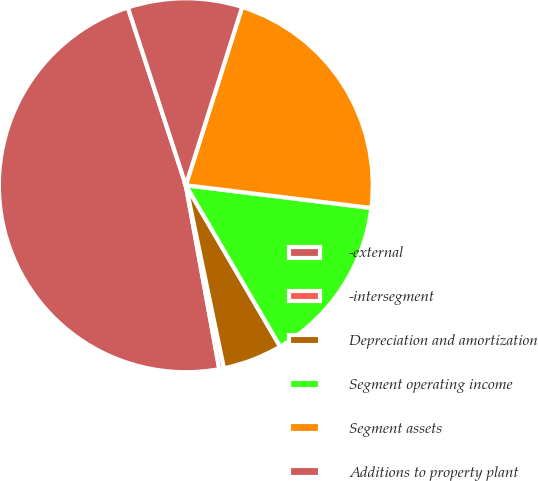Convert chart to OTSL. <chart><loc_0><loc_0><loc_500><loc_500><pie_chart><fcel>-external<fcel>-intersegment<fcel>Depreciation and amortization<fcel>Segment operating income<fcel>Segment assets<fcel>Additions to property plant<nl><fcel>47.85%<fcel>0.4%<fcel>5.15%<fcel>14.64%<fcel>22.07%<fcel>9.89%<nl></chart> 